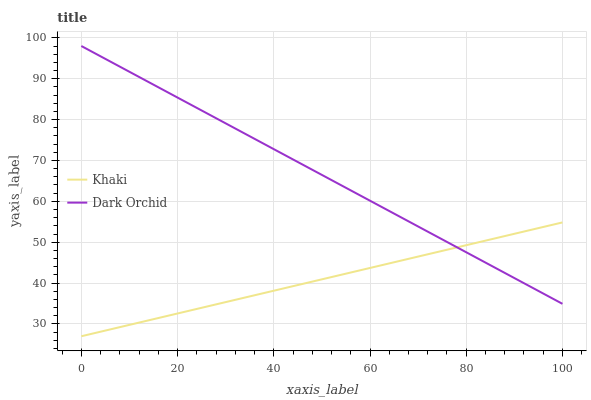Does Khaki have the minimum area under the curve?
Answer yes or no. Yes. Does Dark Orchid have the maximum area under the curve?
Answer yes or no. Yes. Does Dark Orchid have the minimum area under the curve?
Answer yes or no. No. Is Dark Orchid the smoothest?
Answer yes or no. Yes. Is Khaki the roughest?
Answer yes or no. Yes. Is Dark Orchid the roughest?
Answer yes or no. No. Does Khaki have the lowest value?
Answer yes or no. Yes. Does Dark Orchid have the lowest value?
Answer yes or no. No. Does Dark Orchid have the highest value?
Answer yes or no. Yes. Does Dark Orchid intersect Khaki?
Answer yes or no. Yes. Is Dark Orchid less than Khaki?
Answer yes or no. No. Is Dark Orchid greater than Khaki?
Answer yes or no. No. 